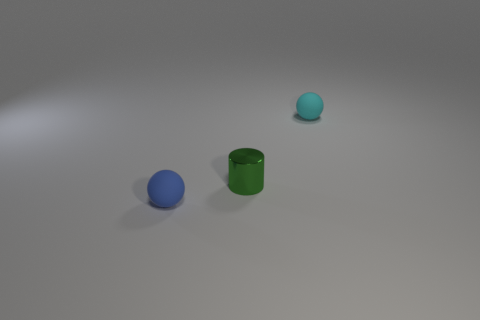Add 1 small rubber things. How many objects exist? 4 Subtract all spheres. How many objects are left? 1 Add 1 tiny matte balls. How many tiny matte balls are left? 3 Add 1 tiny metal things. How many tiny metal things exist? 2 Subtract 0 yellow cubes. How many objects are left? 3 Subtract all tiny purple rubber balls. Subtract all small balls. How many objects are left? 1 